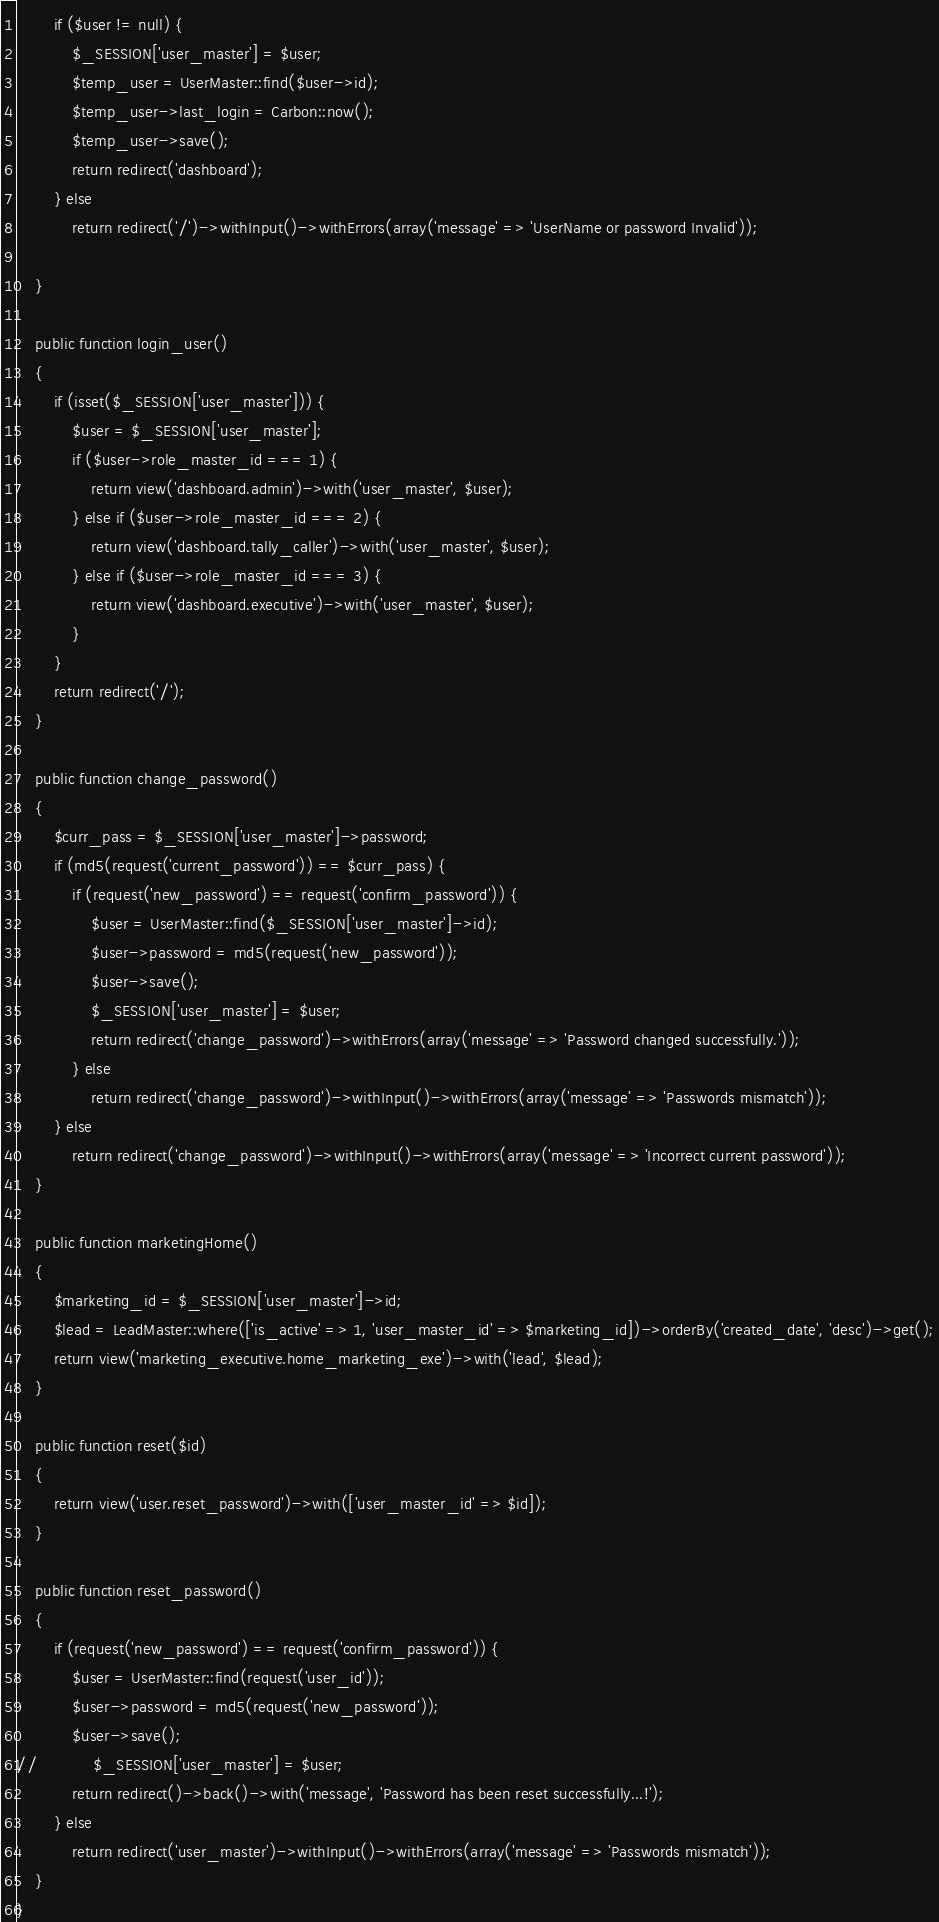<code> <loc_0><loc_0><loc_500><loc_500><_PHP_>        if ($user != null) {
            $_SESSION['user_master'] = $user;
            $temp_user = UserMaster::find($user->id);
            $temp_user->last_login = Carbon::now();
            $temp_user->save();
            return redirect('dashboard');
        } else
            return redirect('/')->withInput()->withErrors(array('message' => 'UserName or password Invalid'));

    }

    public function login_user()
    {
        if (isset($_SESSION['user_master'])) {
            $user = $_SESSION['user_master'];
            if ($user->role_master_id === 1) {
                return view('dashboard.admin')->with('user_master', $user);
            } else if ($user->role_master_id === 2) {
                return view('dashboard.tally_caller')->with('user_master', $user);
            } else if ($user->role_master_id === 3) {
                return view('dashboard.executive')->with('user_master', $user);
            }
        }
        return redirect('/');
    }

    public function change_password()
    {
        $curr_pass = $_SESSION['user_master']->password;
        if (md5(request('current_password')) == $curr_pass) {
            if (request('new_password') == request('confirm_password')) {
                $user = UserMaster::find($_SESSION['user_master']->id);
                $user->password = md5(request('new_password'));
                $user->save();
                $_SESSION['user_master'] = $user;
                return redirect('change_password')->withErrors(array('message' => 'Password changed successfully.'));
            } else
                return redirect('change_password')->withInput()->withErrors(array('message' => 'Passwords mismatch'));
        } else
            return redirect('change_password')->withInput()->withErrors(array('message' => 'Incorrect current password'));
    }

    public function marketingHome()
    {
        $marketing_id = $_SESSION['user_master']->id;
        $lead = LeadMaster::where(['is_active' => 1, 'user_master_id' => $marketing_id])->orderBy('created_date', 'desc')->get();
        return view('marketing_executive.home_marketing_exe')->with('lead', $lead);
    }

    public function reset($id)
    {
        return view('user.reset_password')->with(['user_master_id' => $id]);
    }

    public function reset_password()
    {
        if (request('new_password') == request('confirm_password')) {
            $user = UserMaster::find(request('user_id'));
            $user->password = md5(request('new_password'));
            $user->save();
//            $_SESSION['user_master'] = $user;
            return redirect()->back()->with('message', 'Password has been reset successfully...!');
        } else
            return redirect('user_master')->withInput()->withErrors(array('message' => 'Passwords mismatch'));
    }
}
</code> 